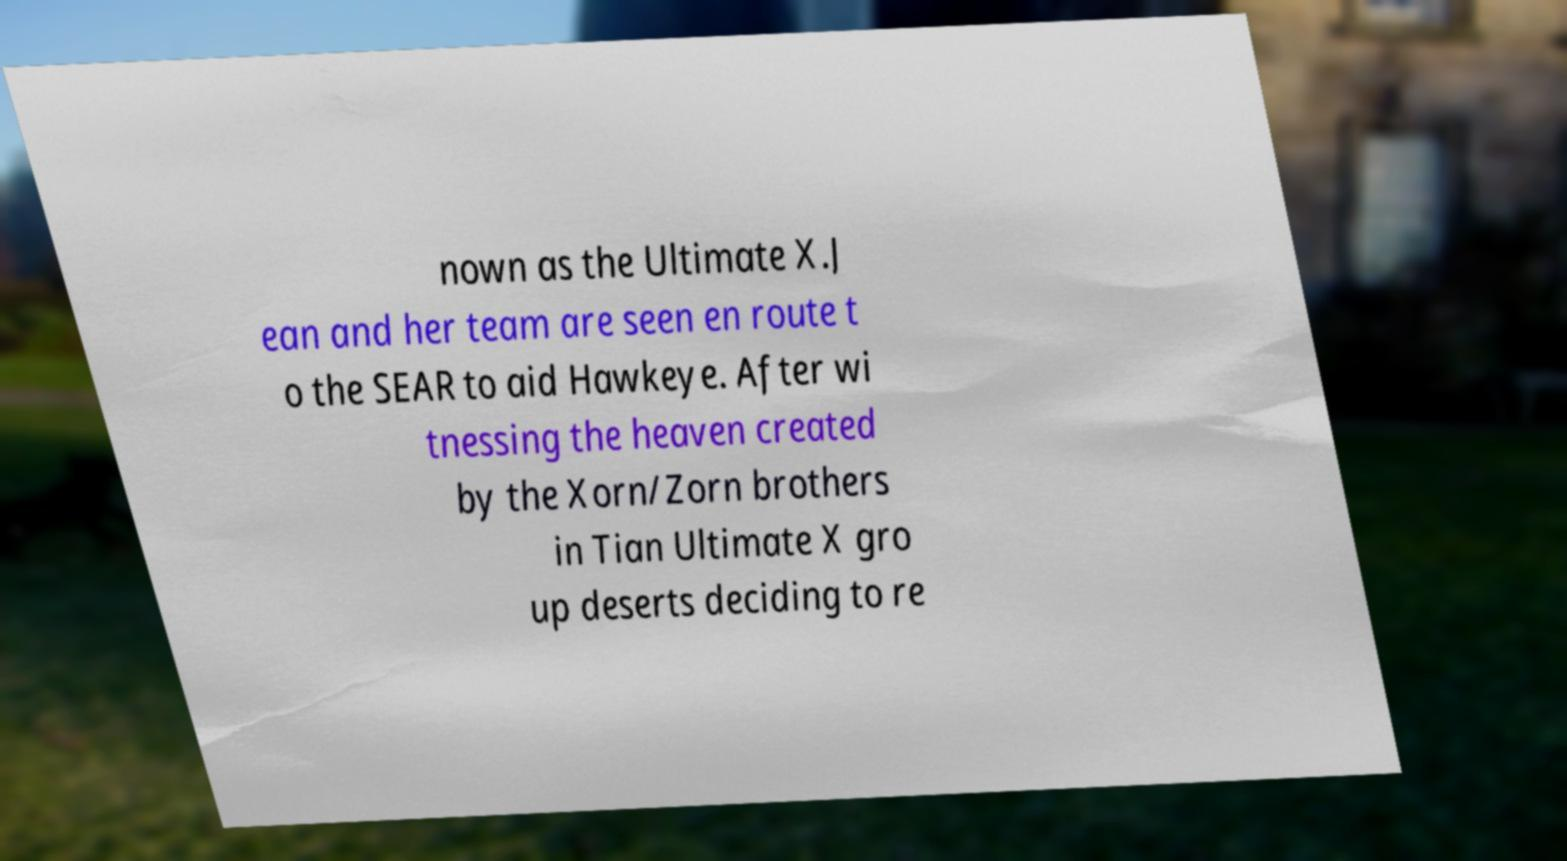I need the written content from this picture converted into text. Can you do that? nown as the Ultimate X.J ean and her team are seen en route t o the SEAR to aid Hawkeye. After wi tnessing the heaven created by the Xorn/Zorn brothers in Tian Ultimate X gro up deserts deciding to re 